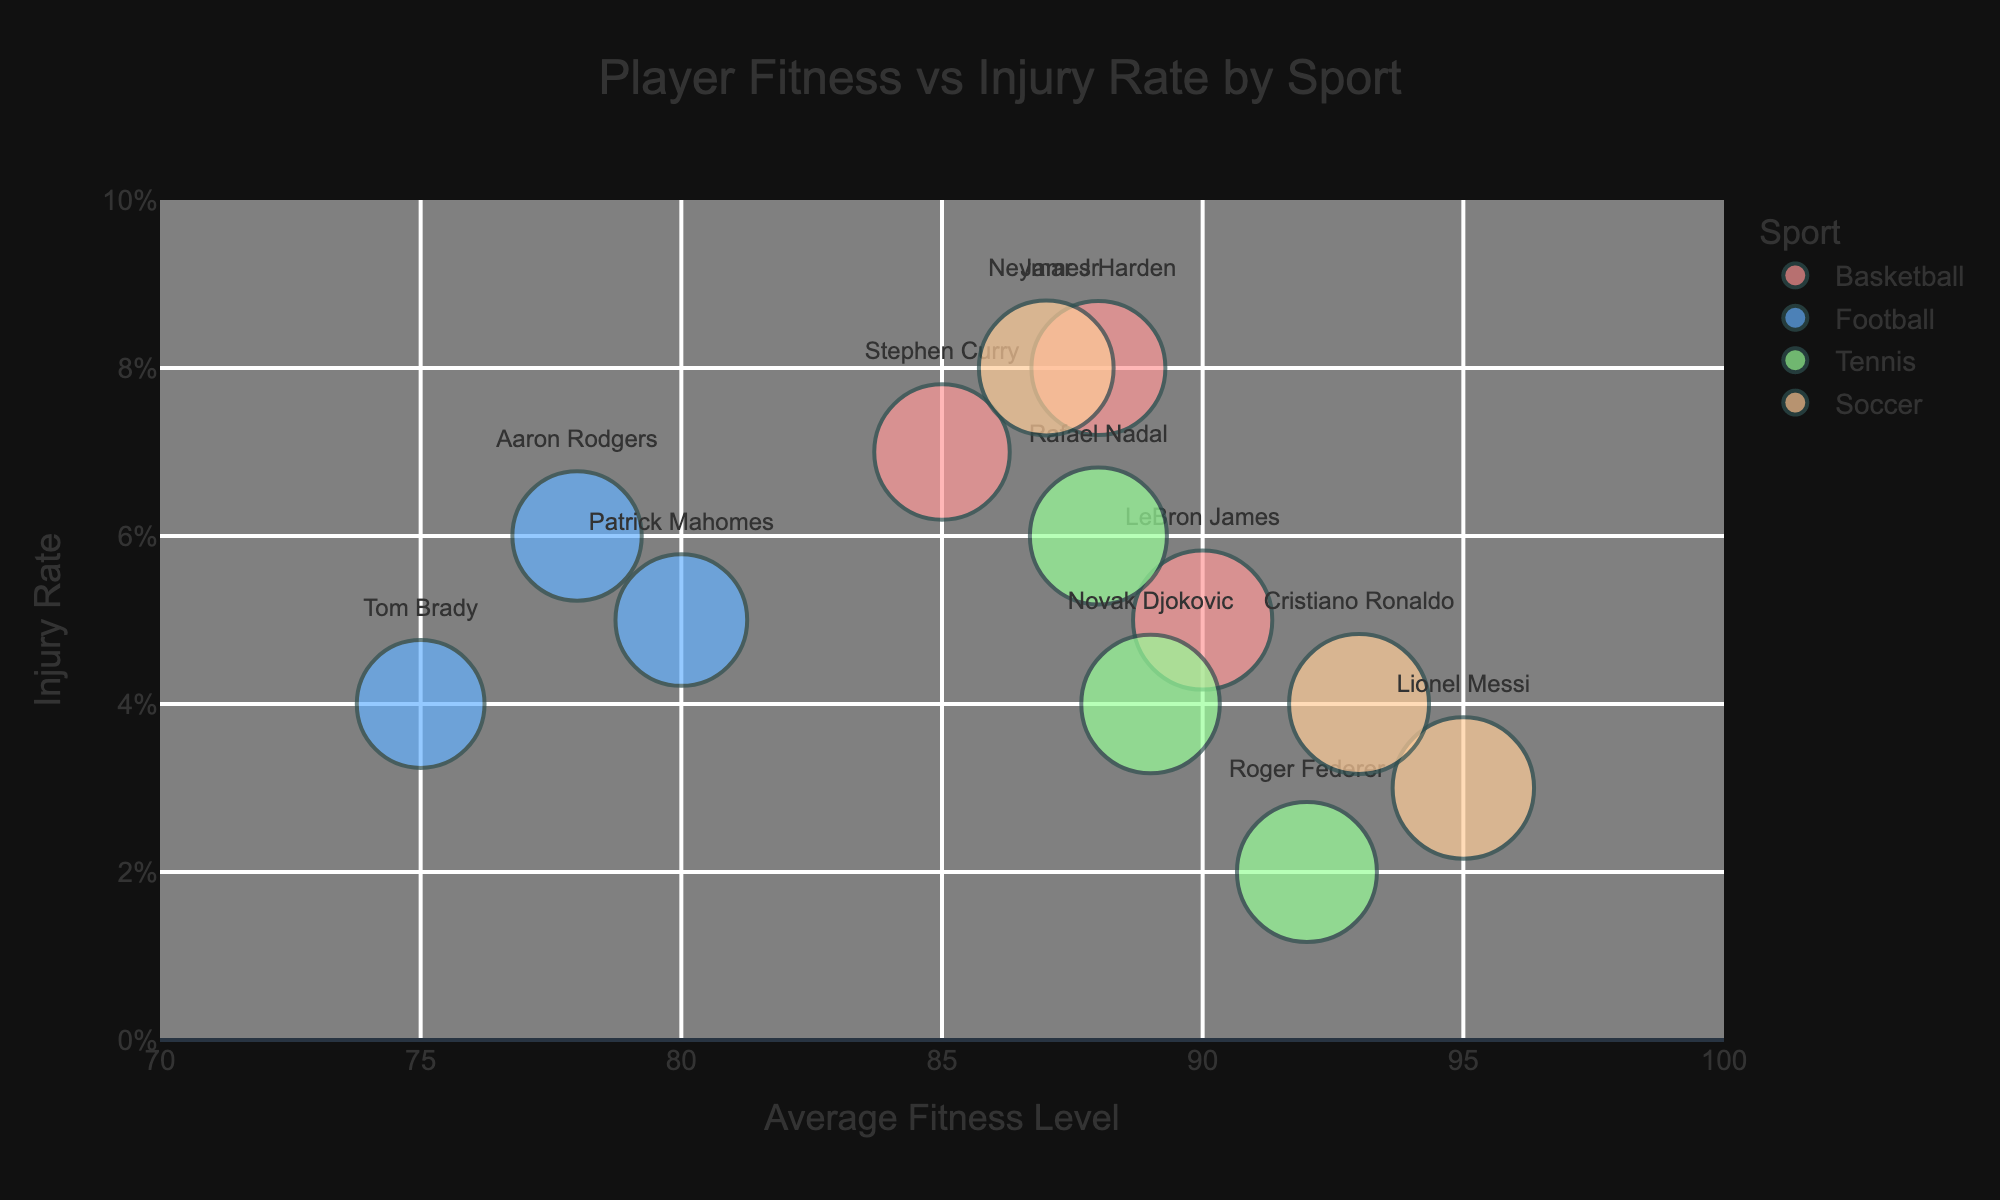Which sport has the highest average fitness level? By looking at the color coding linked to sports in the bubble chart and identifying the bubble with the highest x-axis value, which represents the average fitness level, we can see that soccer has the highest average fitness level, represented by the bubbles for Lionel Messi and Cristiano Ronaldo.
Answer: Soccer What is the title of the chart? The title of the chart is usually displayed prominently at the top of the figure. Here it reads, "Player Fitness vs Injury Rate by Sport."
Answer: Player Fitness vs Injury Rate by Sport Which player has the lowest injury rate? To find the player with the lowest injury rate, we need to identify the bubble farthest down on the y-axis, representing the injury rate. This bubble corresponds to Roger Federer in tennis, who has an injury rate of 0.02.
Answer: Roger Federer Is there a player with an average fitness level above 90 and an injury rate below 0.05? We need to identify bubbles that fall within the specified x-axis (fitness level) and y-axis (injury rate) ranges. Lionel Messi has an average fitness level of 95 and an injury rate of 0.03, meeting both conditions. Roger Federer also fits the criteria with an average fitness level of 92 and an injury rate of 0.02.
Answer: Yes (Lionel Messi and Roger Federer) In which sport is the player with the highest fitness score located? The fitness score is depicted by the size of the bubble. The largest bubble represents Lionel Messi from soccer, with a fitness score of 98.
Answer: Soccer Who has a higher injury rate, LeBron James or Stephen Curry? By comparing the y-axis positions of the bubbles for LeBron James and Stephen Curry, we find that Stephen Curry has a higher injury rate at 0.07 compared to LeBron James' injury rate of 0.05.
Answer: Stephen Curry Which two players have the same injury severity score of 2 in basketball? Looking at the bubble chart and focusing on basketball players (color-coded), we can see that both Stephen Curry and James Harden have an injury severity score of 2.
Answer: Stephen Curry and James Harden What is the default color used to represent tennis players in the chart? Observing the bubble colors linked to each sport, it is clear that tennis players are represented using a color distinctly separate from basketball, football, and soccer. The specific color for tennis players in the provided code is "#99FF99".
Answer: Green How do soccer players compare to tennis players in terms of average fitness levels? We observe the x-axis values (average fitness levels) for the bubbles representing soccer and tennis players. Soccer players (Messi, Ronaldo, Neymar) have high fitness levels ranging from 87 to 95, while tennis players (Federer, Nadal, Djokovic) have fitness levels between 88 and 92. Generally, soccer players have higher average fitness levels.
Answer: Soccer players have higher average fitness levels What is the range of the y-axis on this chart? To determine the range of the y-axis, we refer to the axis labeling in the chart description. The y-axis labeled "Injury Rate" ranges from 0 to 0.1.
Answer: 0 to 0.1 